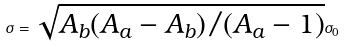Convert formula to latex. <formula><loc_0><loc_0><loc_500><loc_500>\sigma = \sqrt { A _ { b } ( A _ { a } - A _ { b } ) / ( A _ { a } - 1 ) } \sigma _ { 0 }</formula> 